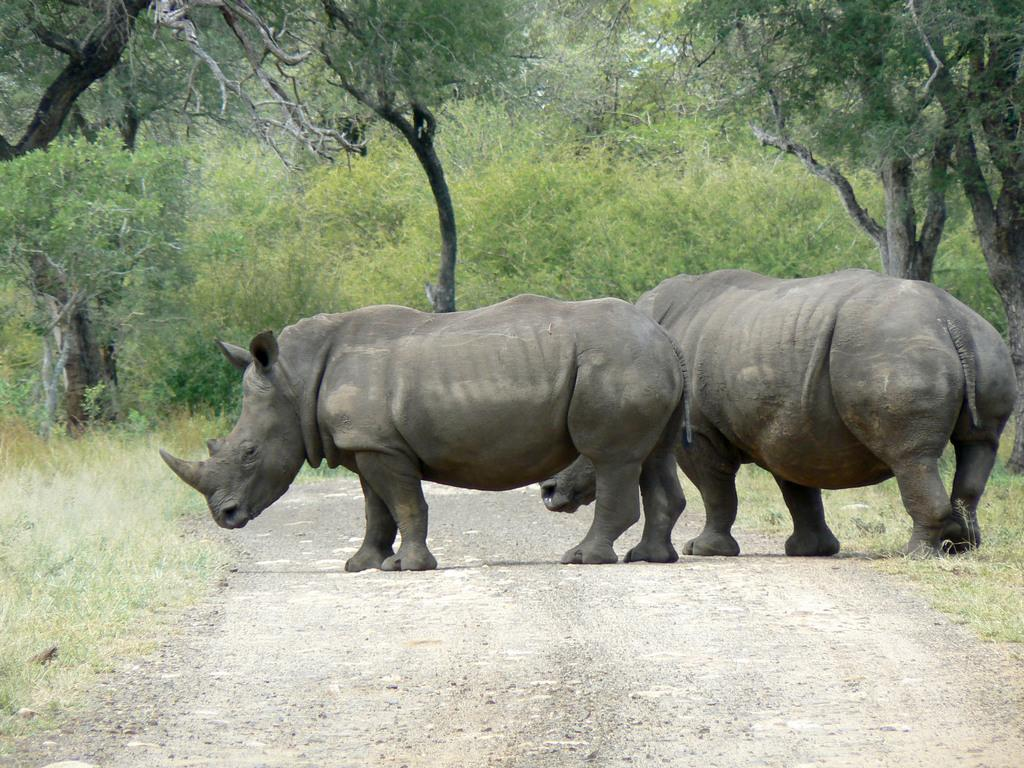What animals are in the foreground of the image? There are rhinoceros in the foreground of the image. What type of vegetation can be seen in the background of the image? There are trees in the background of the image. What type of terrain is visible at the bottom of the image? There is grass at the bottom of the image. What is the surface on which the rhinoceros and grass are situated? There is ground visible in the image. What is the purpose of the copy of the rhinoceros in the image? There is no copy of the rhinoceros in the image; it is a real animal. 